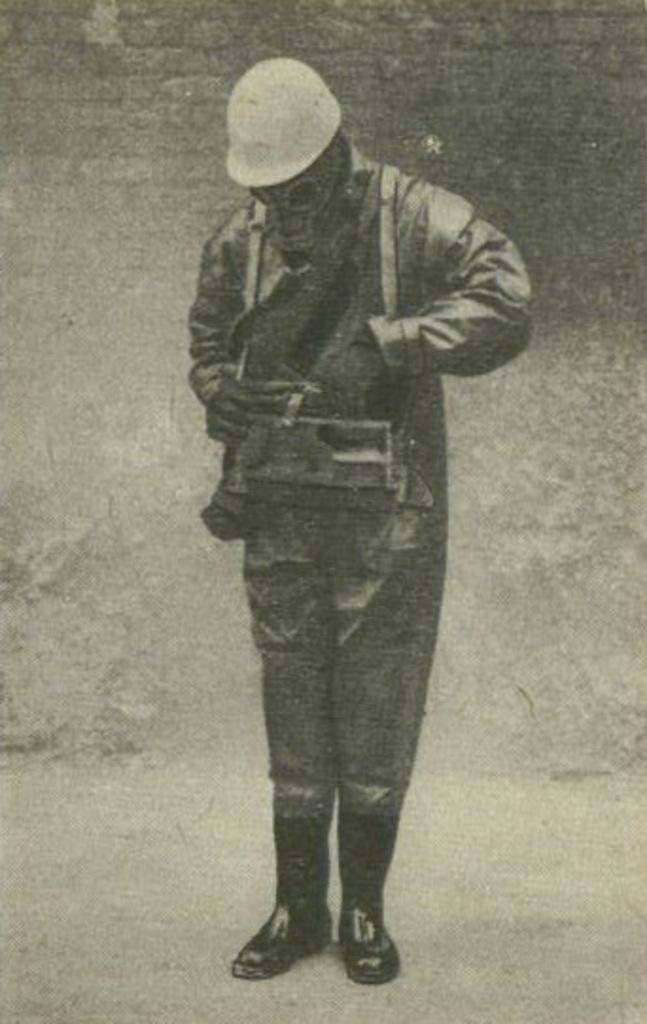What is the color scheme of the image? The image is black and white. Can you describe the person in the image? The person in the image is wearing a uniform, helmet, and mask. What type of frame is holding the receipt in the image? There is no frame or receipt present in the image. 